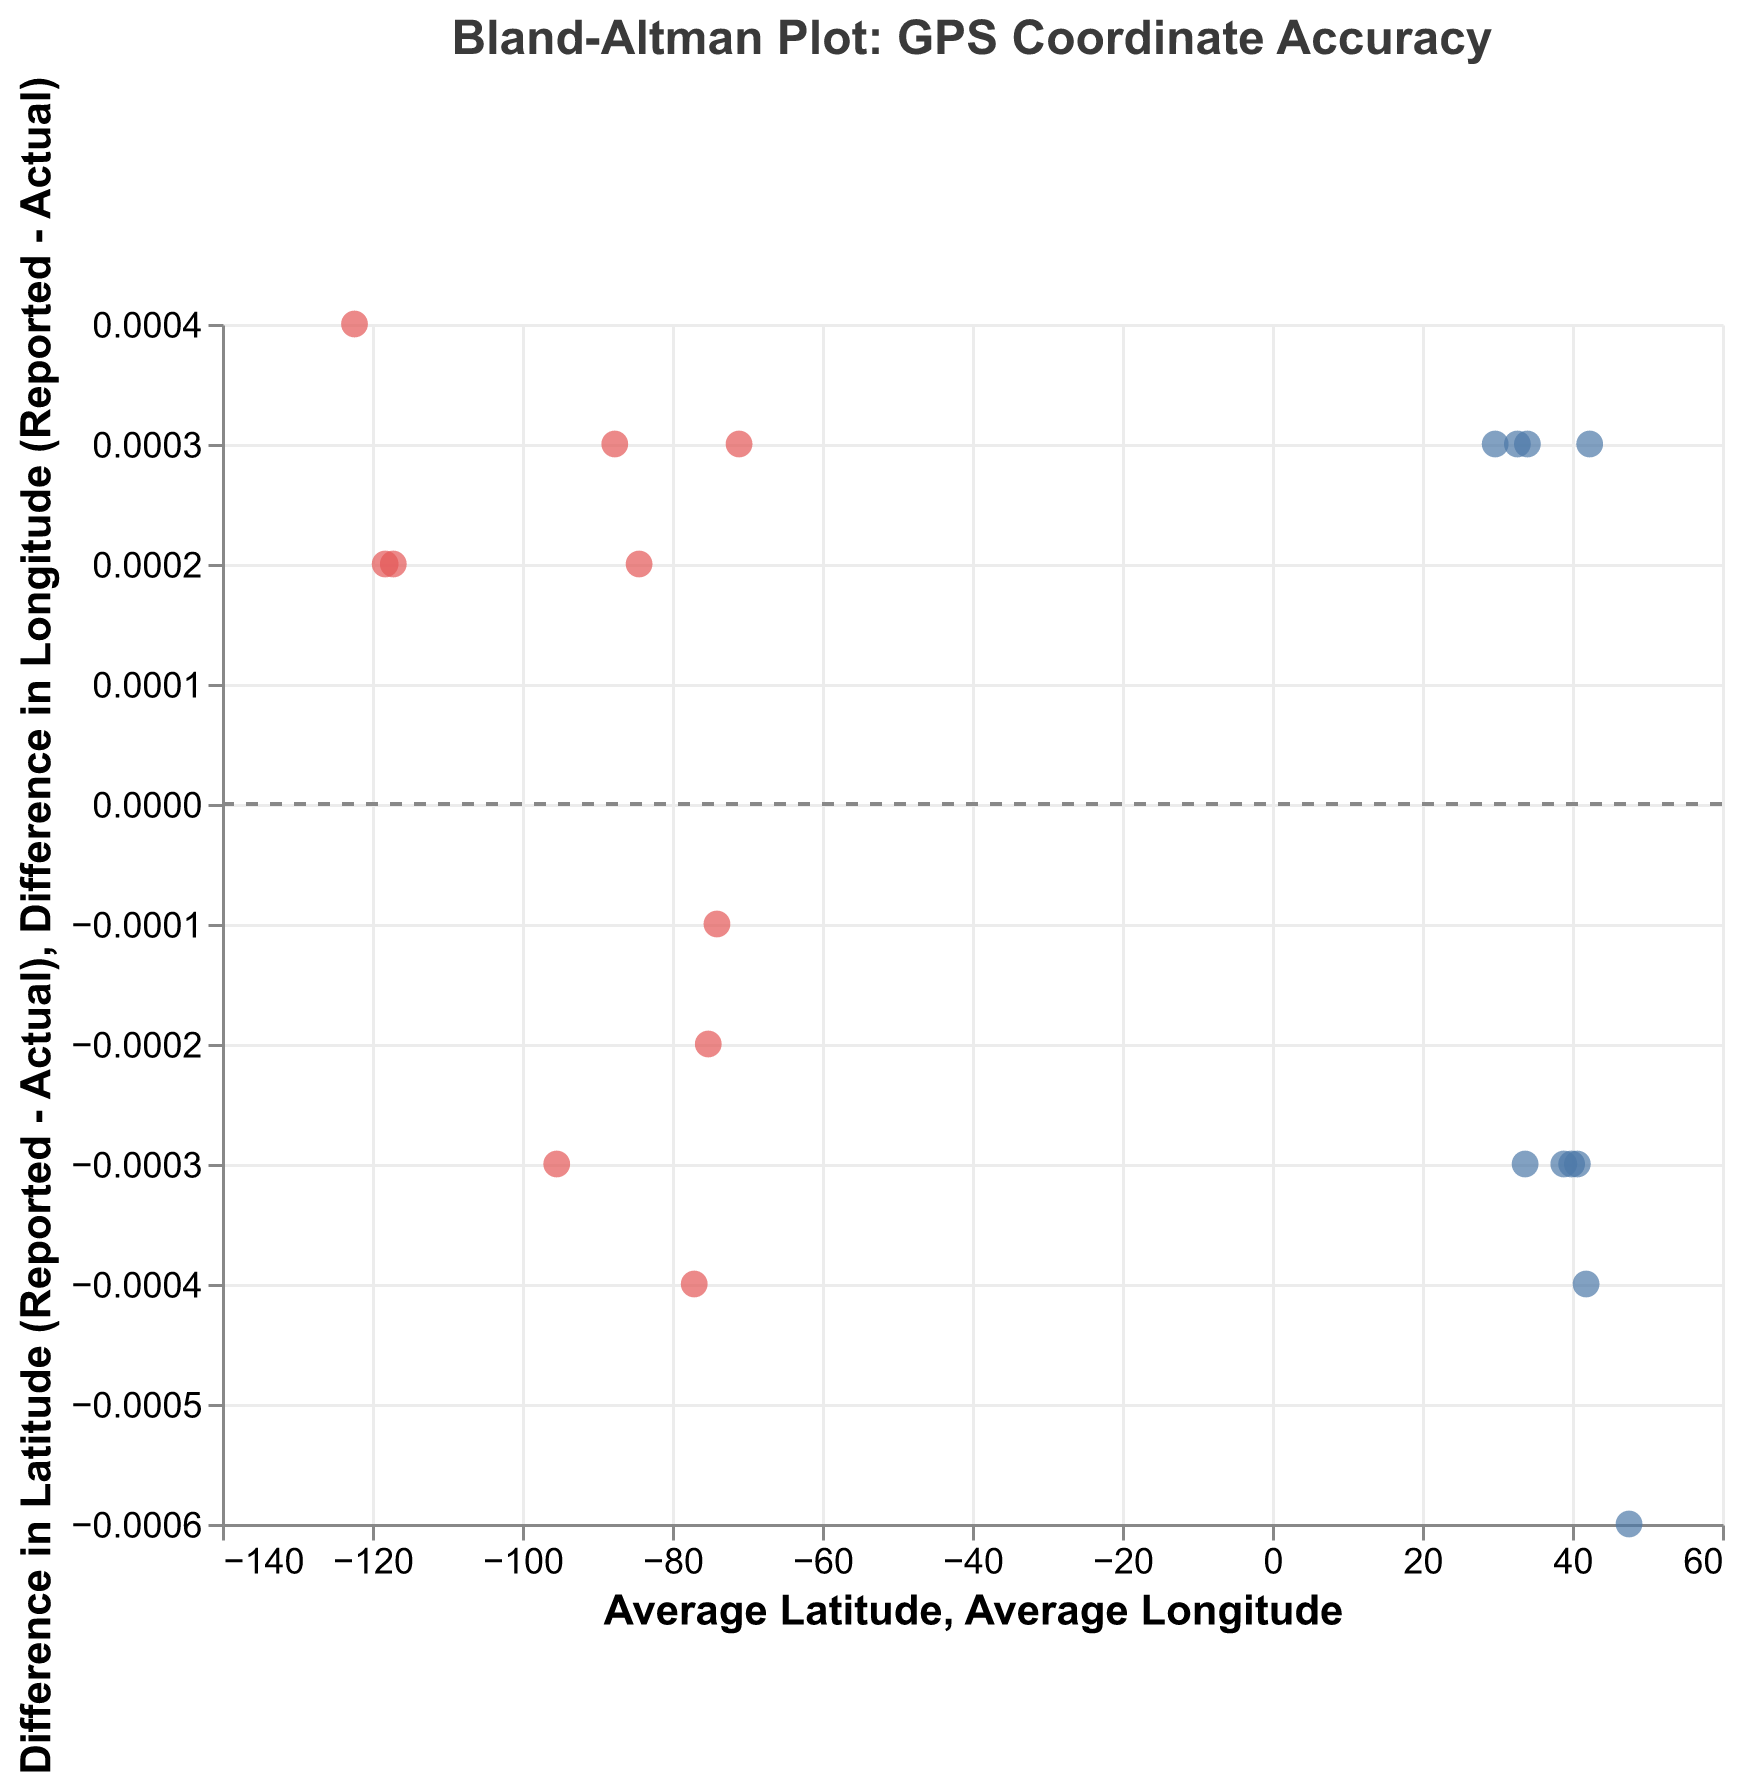What is the title of the plot? The title of the plot is displayed at the top and reads "Bland-Altman Plot: GPS Coordinate Accuracy."
Answer: Bland-Altman Plot: GPS Coordinate Accuracy How many data points are there in the plot? Each point on the plot represents a data point, and there are 10 unique callsigns displayed (from Alpha1 to Juliet10), indicating 10 data points.
Answer: 10 What does the y-axis represent in the Average Latitude vs. Difference in Latitude plot? The y-axis represents the difference in latitude (Reported Latitude - Actual Latitude).
Answer: Difference in Latitude (Reported - Actual) Which callsign has the highest latitude difference? By observing the points and tooltips, "Alpha1" has the highest positive difference in latitude.
Answer: Alpha1 Which callsign has the smallest longitude difference? By looking at the lowest point along the y-axis in the Longitude plot, "Bravo2" has the smallest difference, close to zero.
Answer: Bravo2 What is the trendline at y=0? The plot includes a horizontal dashed line at y=0, indicating where there would be no difference between reported and actual coordinates.
Answer: no difference line What are the average latitude and difference in latitude for Delta4? Hover over the point for "Delta4" to read the tooltip: Average Latitude is 41.8783 and Difference in Latitude is -0.0004.
Answer: Average Latitude: 41.8783, Difference in Latitude: -0.0004 Which has greater variability, Latitude or Longitude differences? Compare the spread of points in both the latitude and longitude plots. Latitude differences show more spread, indicating greater variability.
Answer: Latitude What are the average longitude and difference in longitude for Foxtrot6? Hover over the point for "Foxtrot6" to read the tooltip: Average Longitude is -75.1651 and Difference in Longitude is 0.0002.
Answer: Average Longitude: -75.1651, Difference in Longitude: 0.0002 